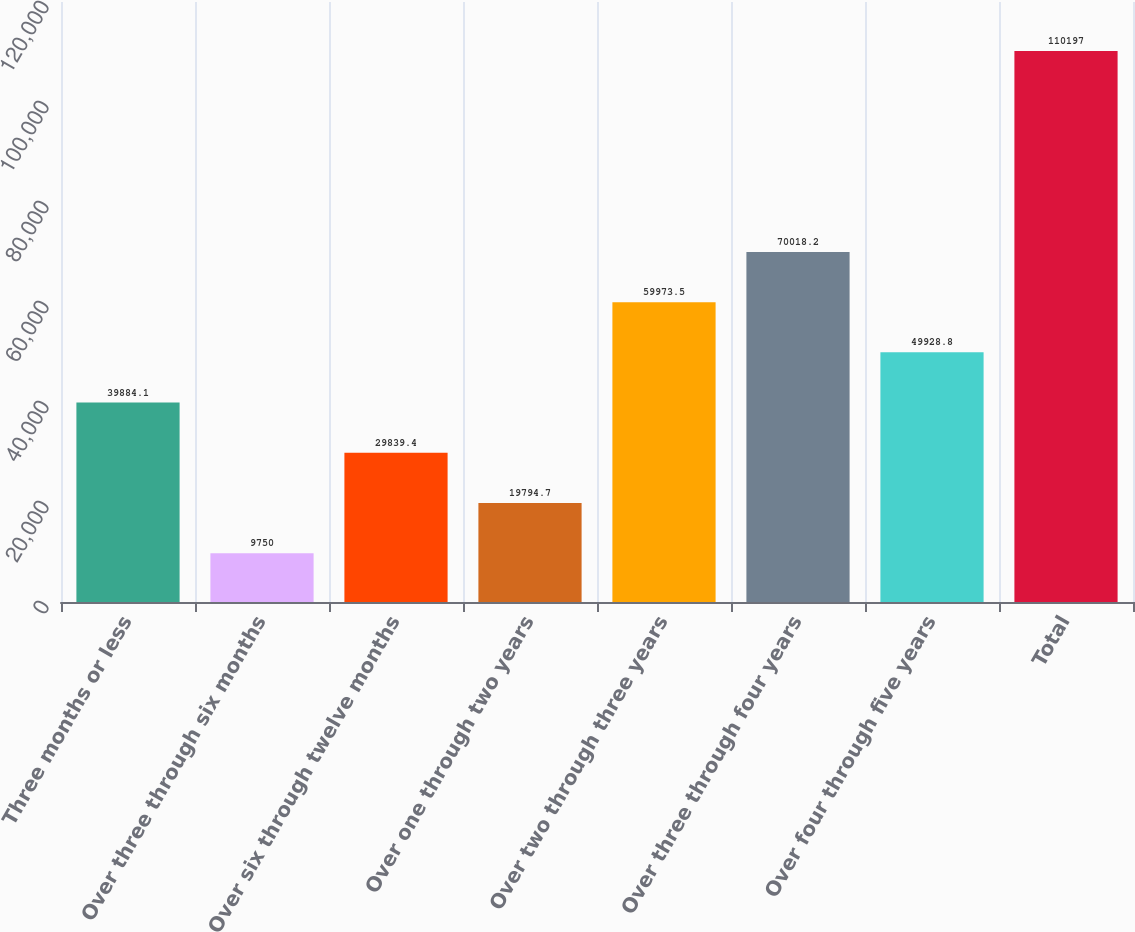Convert chart. <chart><loc_0><loc_0><loc_500><loc_500><bar_chart><fcel>Three months or less<fcel>Over three through six months<fcel>Over six through twelve months<fcel>Over one through two years<fcel>Over two through three years<fcel>Over three through four years<fcel>Over four through five years<fcel>Total<nl><fcel>39884.1<fcel>9750<fcel>29839.4<fcel>19794.7<fcel>59973.5<fcel>70018.2<fcel>49928.8<fcel>110197<nl></chart> 